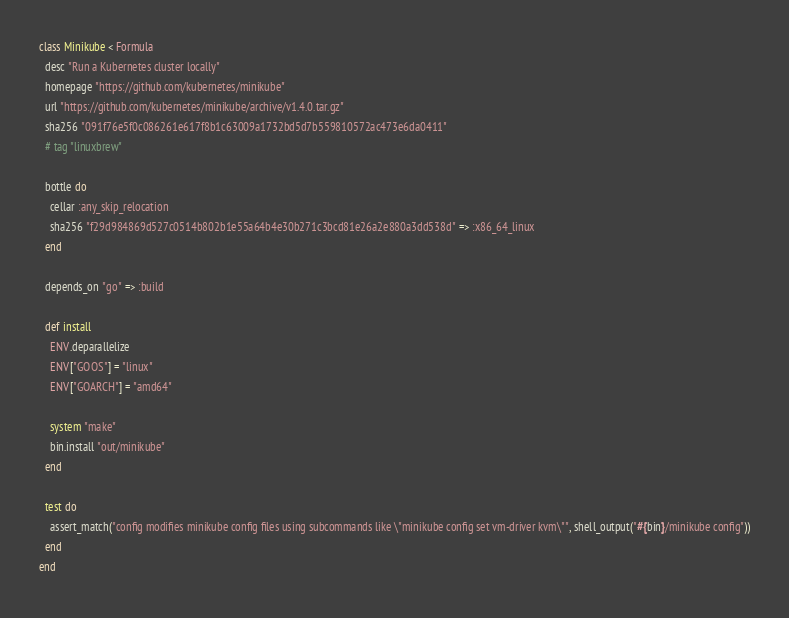<code> <loc_0><loc_0><loc_500><loc_500><_Ruby_>class Minikube < Formula
  desc "Run a Kubernetes cluster locally"
  homepage "https://github.com/kubernetes/minikube"
  url "https://github.com/kubernetes/minikube/archive/v1.4.0.tar.gz"
  sha256 "091f76e5f0c086261e617f8b1c63009a1732bd5d7b559810572ac473e6da0411"
  # tag "linuxbrew"

  bottle do
    cellar :any_skip_relocation
    sha256 "f29d984869d527c0514b802b1e55a64b4e30b271c3bcd81e26a2e880a3dd538d" => :x86_64_linux
  end

  depends_on "go" => :build

  def install
    ENV.deparallelize
    ENV["GOOS"] = "linux"
    ENV["GOARCH"] = "amd64"

    system "make"
    bin.install "out/minikube"
  end

  test do
    assert_match("config modifies minikube config files using subcommands like \"minikube config set vm-driver kvm\"", shell_output("#{bin}/minikube config"))
  end
end
</code> 